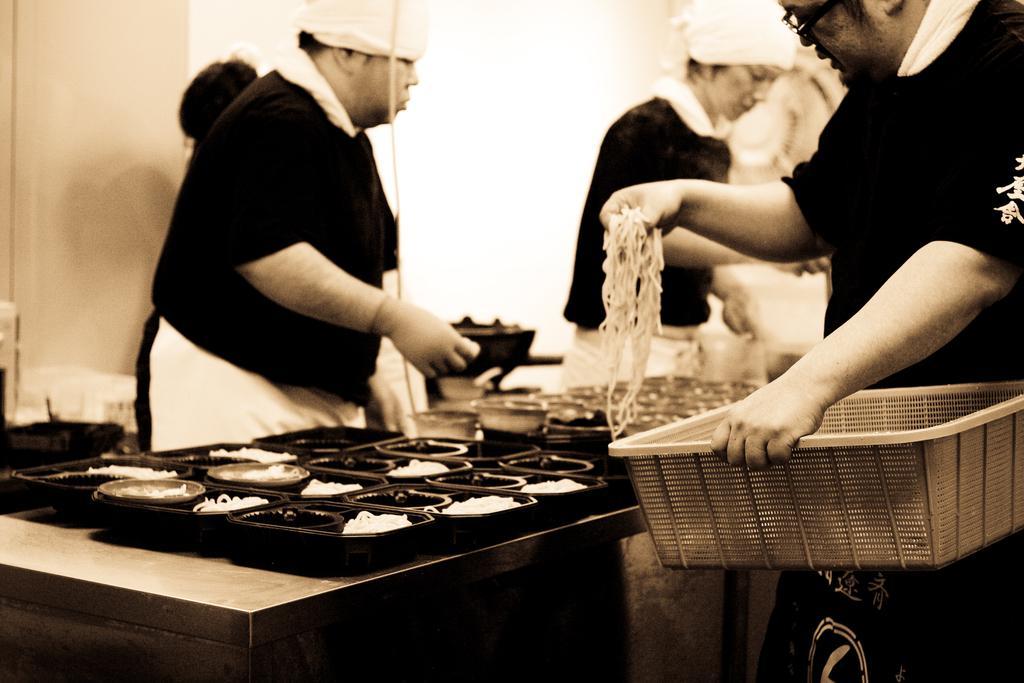In one or two sentences, can you explain what this image depicts? In this picture, we see four people are standing. The man on the right side is standing and he is wearing the spectacles. He is holding a basket containing noodles in his hand and he is putting the noodles in the bowl. In front of them, we see a table on which a tray containing bowls and empty bowls are placed. In the background, we see a white wall and an object in black color. This picture might be clicked in the kitchen. 